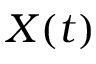Convert formula to latex. <formula><loc_0><loc_0><loc_500><loc_500>X ( t )</formula> 